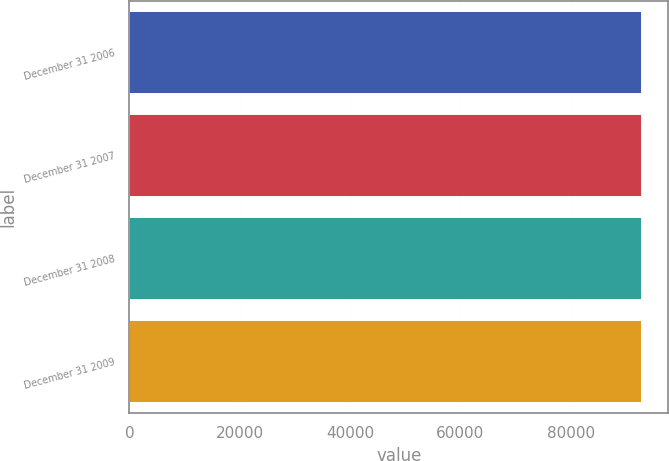<chart> <loc_0><loc_0><loc_500><loc_500><bar_chart><fcel>December 31 2006<fcel>December 31 2007<fcel>December 31 2008<fcel>December 31 2009<nl><fcel>92992<fcel>92992.1<fcel>92992.2<fcel>92992.3<nl></chart> 